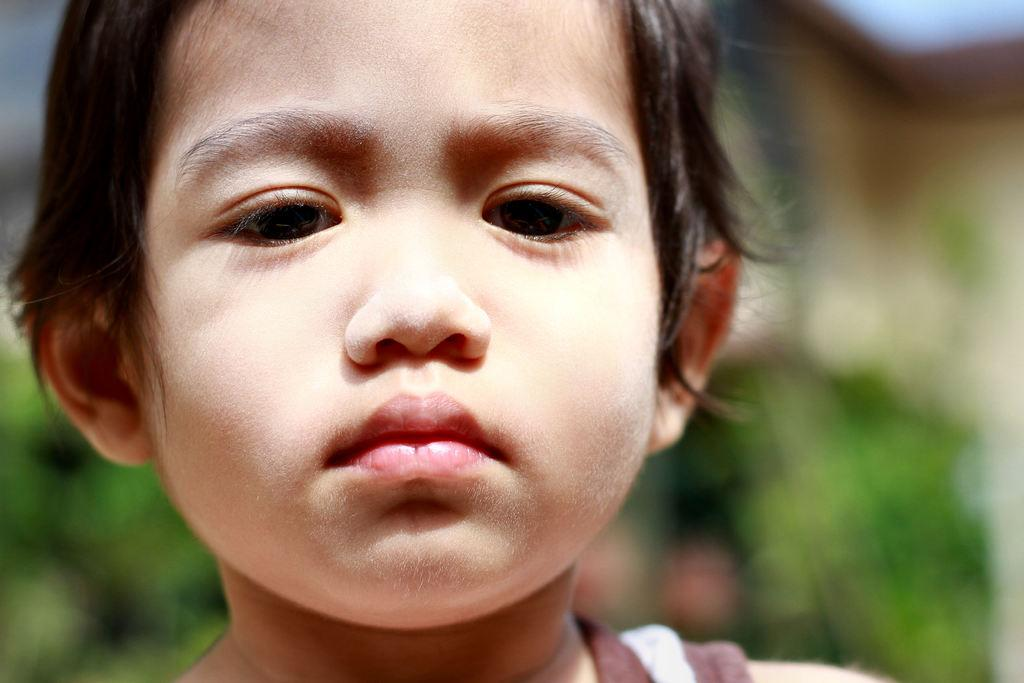What is the main subject of the image? The main subject of the image is a child. What is the child doing in the image? The child is looking at a picture. Can you describe the background of the image? The background of the image is blurred. What type of wire is visible in the image? There is no wire present in the image. What is the condition of the liquid in the image? There is no liquid present in the image. 